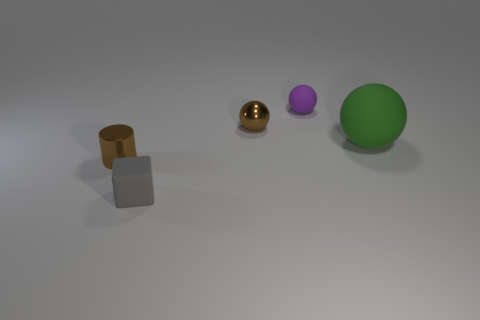Add 3 big green rubber cylinders. How many objects exist? 8 Subtract all matte balls. How many balls are left? 1 Subtract all balls. How many objects are left? 2 Subtract 3 balls. How many balls are left? 0 Add 4 big yellow objects. How many big yellow objects exist? 4 Subtract all purple balls. How many balls are left? 2 Subtract 0 green cylinders. How many objects are left? 5 Subtract all green cylinders. Subtract all red balls. How many cylinders are left? 1 Subtract all purple rubber objects. Subtract all brown objects. How many objects are left? 2 Add 5 gray rubber blocks. How many gray rubber blocks are left? 6 